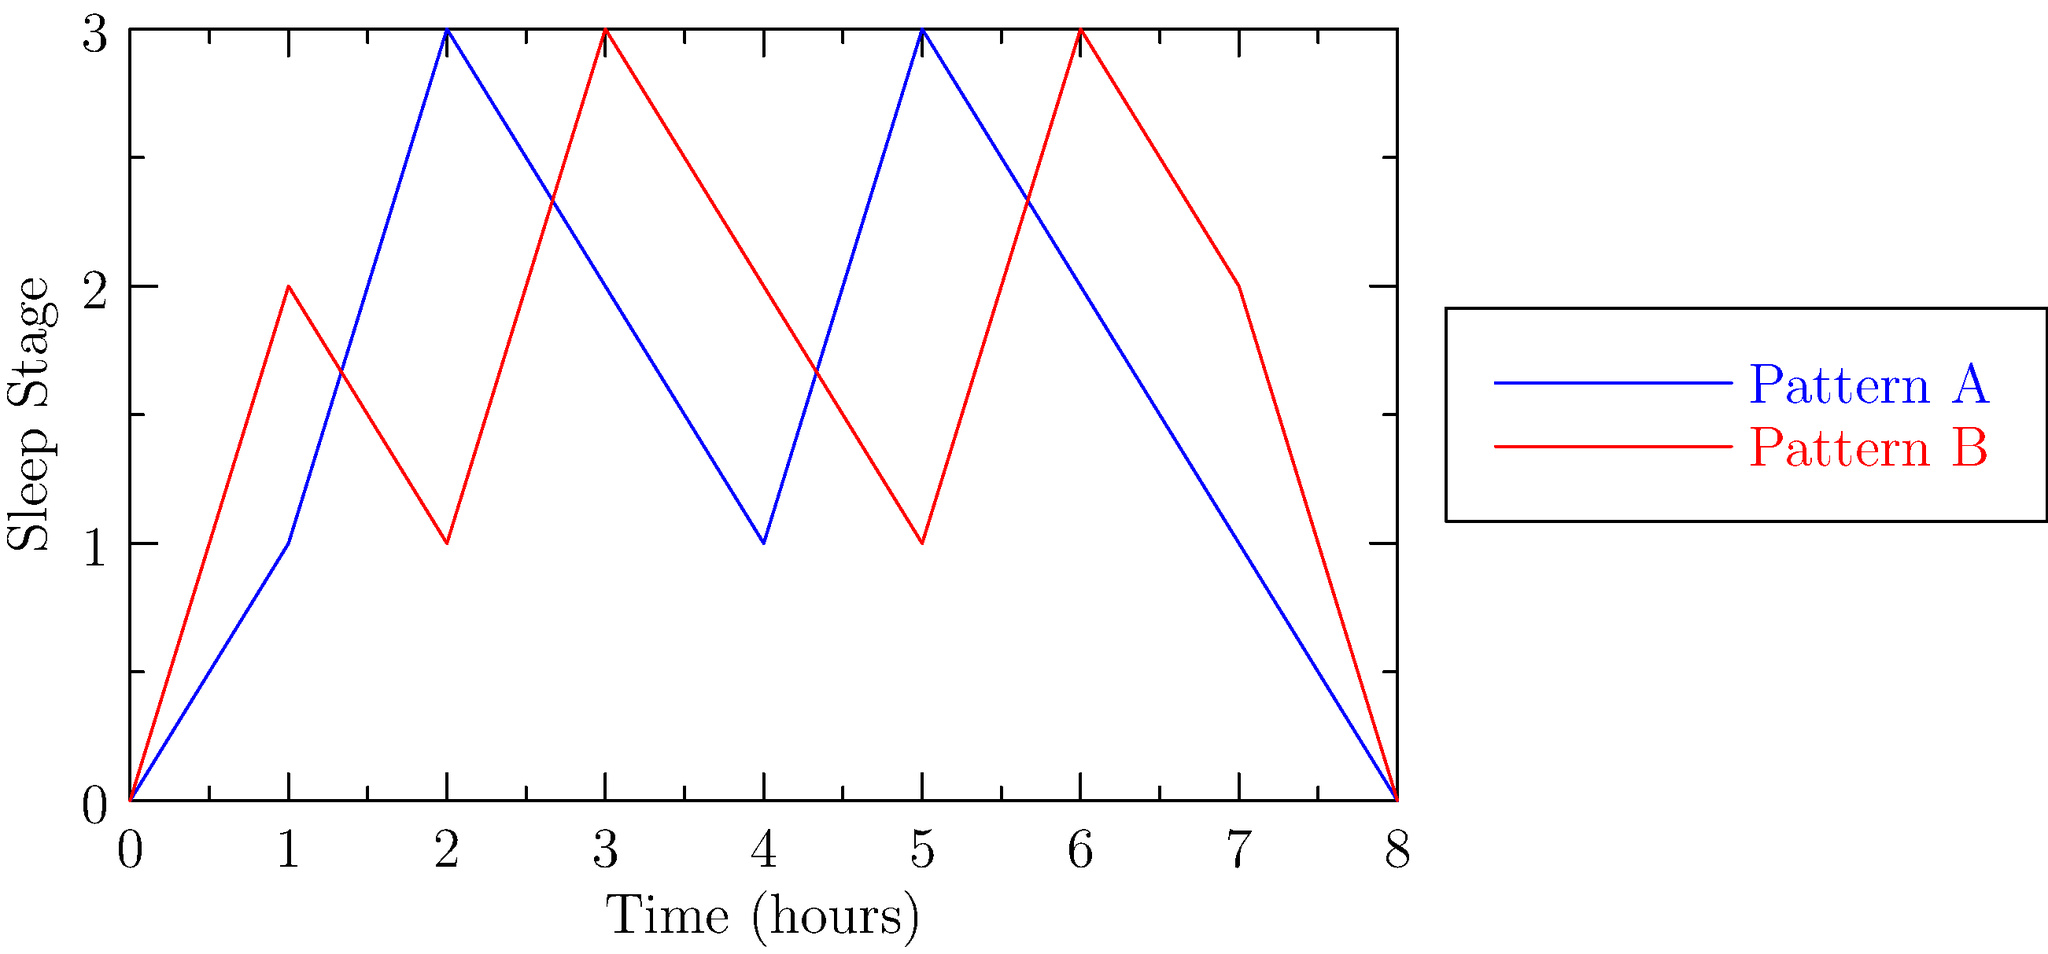Analyze the two sleep cycle patterns shown in the graph. Which pattern demonstrates a higher frequency of transitions between sleep stages, and what implications might this have for sleep quality and dream recall? To answer this question, we need to follow these steps:

1. Examine both patterns:
   - Pattern A (blue line) shows 4 complete cycles over 8 hours.
   - Pattern B (red line) shows 5 complete cycles over 8 hours.

2. Compare the frequency of transitions:
   - Pattern B has more frequent transitions between sleep stages.
   - It completes 5 cycles in the same time Pattern A completes 4.

3. Understand the implications:
   a) Sleep Quality:
      - More frequent transitions (Pattern B) may lead to fragmented sleep.
      - This could result in less time spent in deep, restorative sleep stages.
      - Potentially lower overall sleep quality for Pattern B.

   b) Dream Recall:
      - Dreams typically occur during REM sleep (highest points on the graph).
      - Pattern B shows more frequent REM periods.
      - This could lead to increased opportunities for dreaming.
      - More transitions may cause more awakenings near REM periods.
      - Awakenings near REM increase the likelihood of dream recall.

4. Conclusion:
   Pattern B demonstrates a higher frequency of transitions between sleep stages. This may result in potentially lower sleep quality due to fragmentation, but could lead to increased dream recall due to more frequent REM periods and potential awakenings near these periods.
Answer: Pattern B; lower sleep quality, higher dream recall potential 